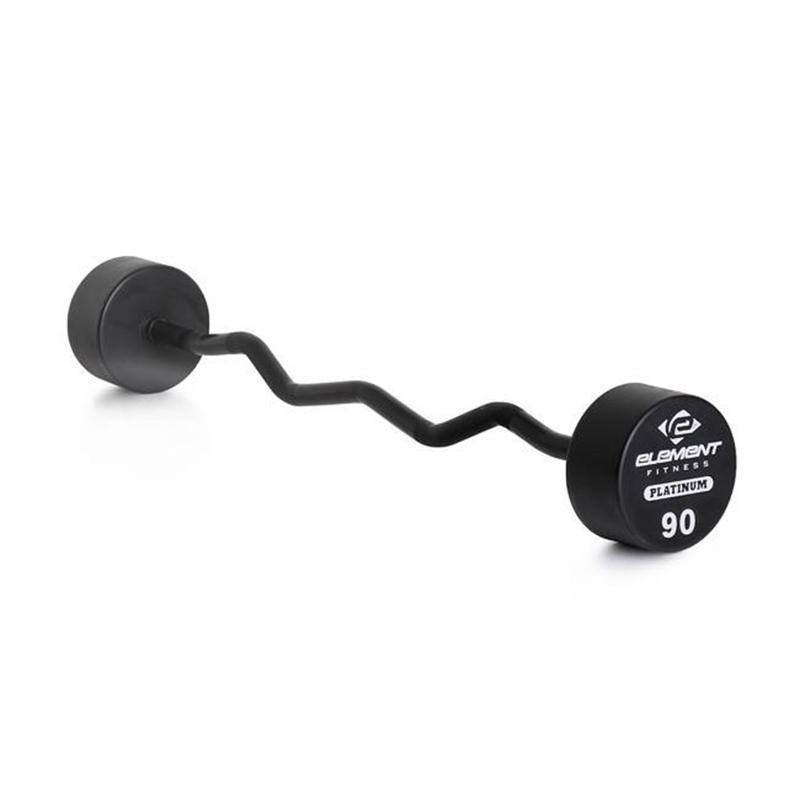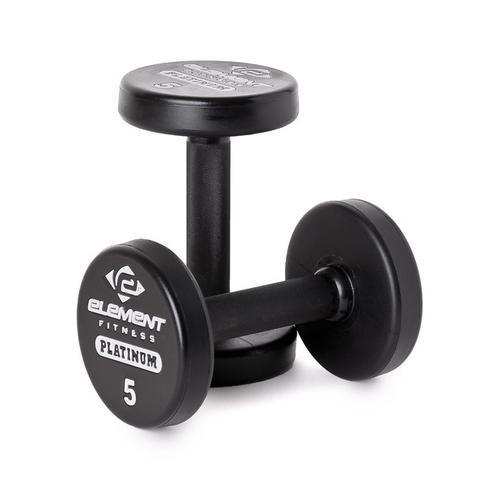The first image is the image on the left, the second image is the image on the right. Given the left and right images, does the statement "The left image shows at least three black barbells." hold true? Answer yes or no. No. 